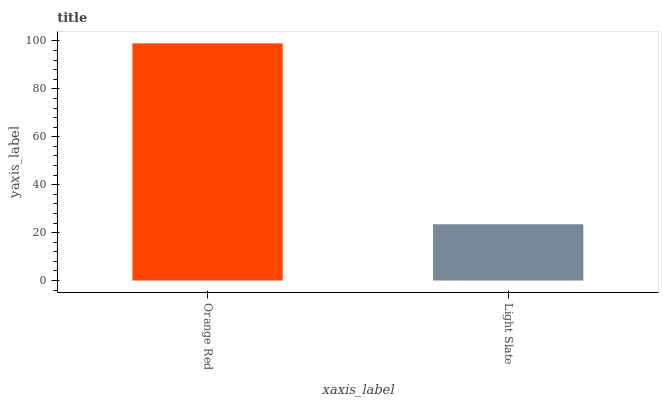Is Light Slate the minimum?
Answer yes or no. Yes. Is Orange Red the maximum?
Answer yes or no. Yes. Is Light Slate the maximum?
Answer yes or no. No. Is Orange Red greater than Light Slate?
Answer yes or no. Yes. Is Light Slate less than Orange Red?
Answer yes or no. Yes. Is Light Slate greater than Orange Red?
Answer yes or no. No. Is Orange Red less than Light Slate?
Answer yes or no. No. Is Orange Red the high median?
Answer yes or no. Yes. Is Light Slate the low median?
Answer yes or no. Yes. Is Light Slate the high median?
Answer yes or no. No. Is Orange Red the low median?
Answer yes or no. No. 